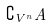<formula> <loc_0><loc_0><loc_500><loc_500>\complement _ { V ^ { n } } A</formula> 